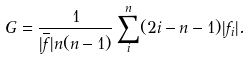Convert formula to latex. <formula><loc_0><loc_0><loc_500><loc_500>G = \frac { 1 } { | \overline { f } | n ( n - 1 ) } \sum _ { i } ^ { n } ( 2 i - n - 1 ) | f _ { i } | .</formula> 